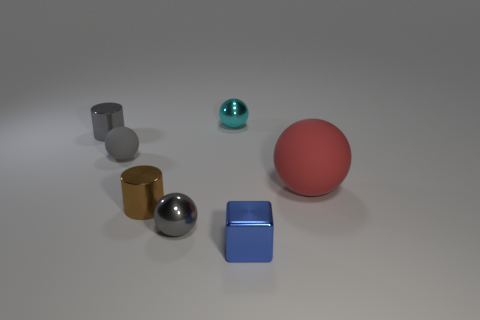There is a blue cube; is it the same size as the red matte ball right of the brown shiny thing?
Ensure brevity in your answer.  No. What is the size of the matte sphere that is to the right of the small cylinder in front of the matte ball on the right side of the tiny metal block?
Keep it short and to the point. Large. There is a metallic cylinder behind the small brown metallic cylinder; what size is it?
Offer a very short reply. Small. There is a tiny blue object that is made of the same material as the tiny cyan ball; what is its shape?
Give a very brief answer. Cube. Does the gray ball on the left side of the brown metallic object have the same material as the cyan thing?
Your response must be concise. No. What number of other things are there of the same material as the large red sphere
Make the answer very short. 1. What number of objects are either rubber things to the right of the small cyan metallic sphere or things that are left of the blue cube?
Offer a very short reply. 6. There is a rubber thing to the right of the blue metal object; is it the same shape as the matte thing that is to the left of the tiny cyan object?
Your answer should be compact. Yes. What shape is the brown object that is the same size as the gray shiny sphere?
Give a very brief answer. Cylinder. What number of shiny things are balls or cyan objects?
Offer a terse response. 2. 